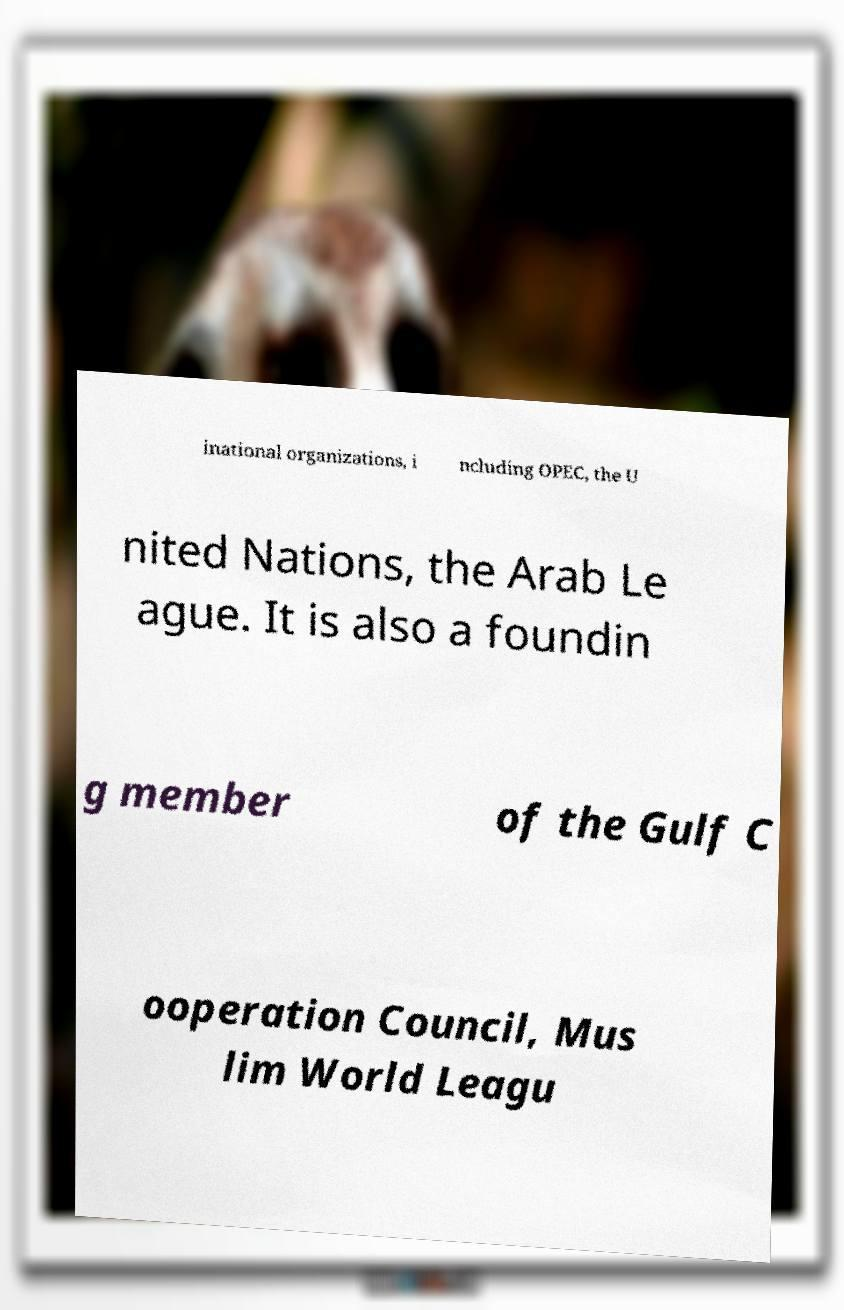Could you extract and type out the text from this image? inational organizations, i ncluding OPEC, the U nited Nations, the Arab Le ague. It is also a foundin g member of the Gulf C ooperation Council, Mus lim World Leagu 